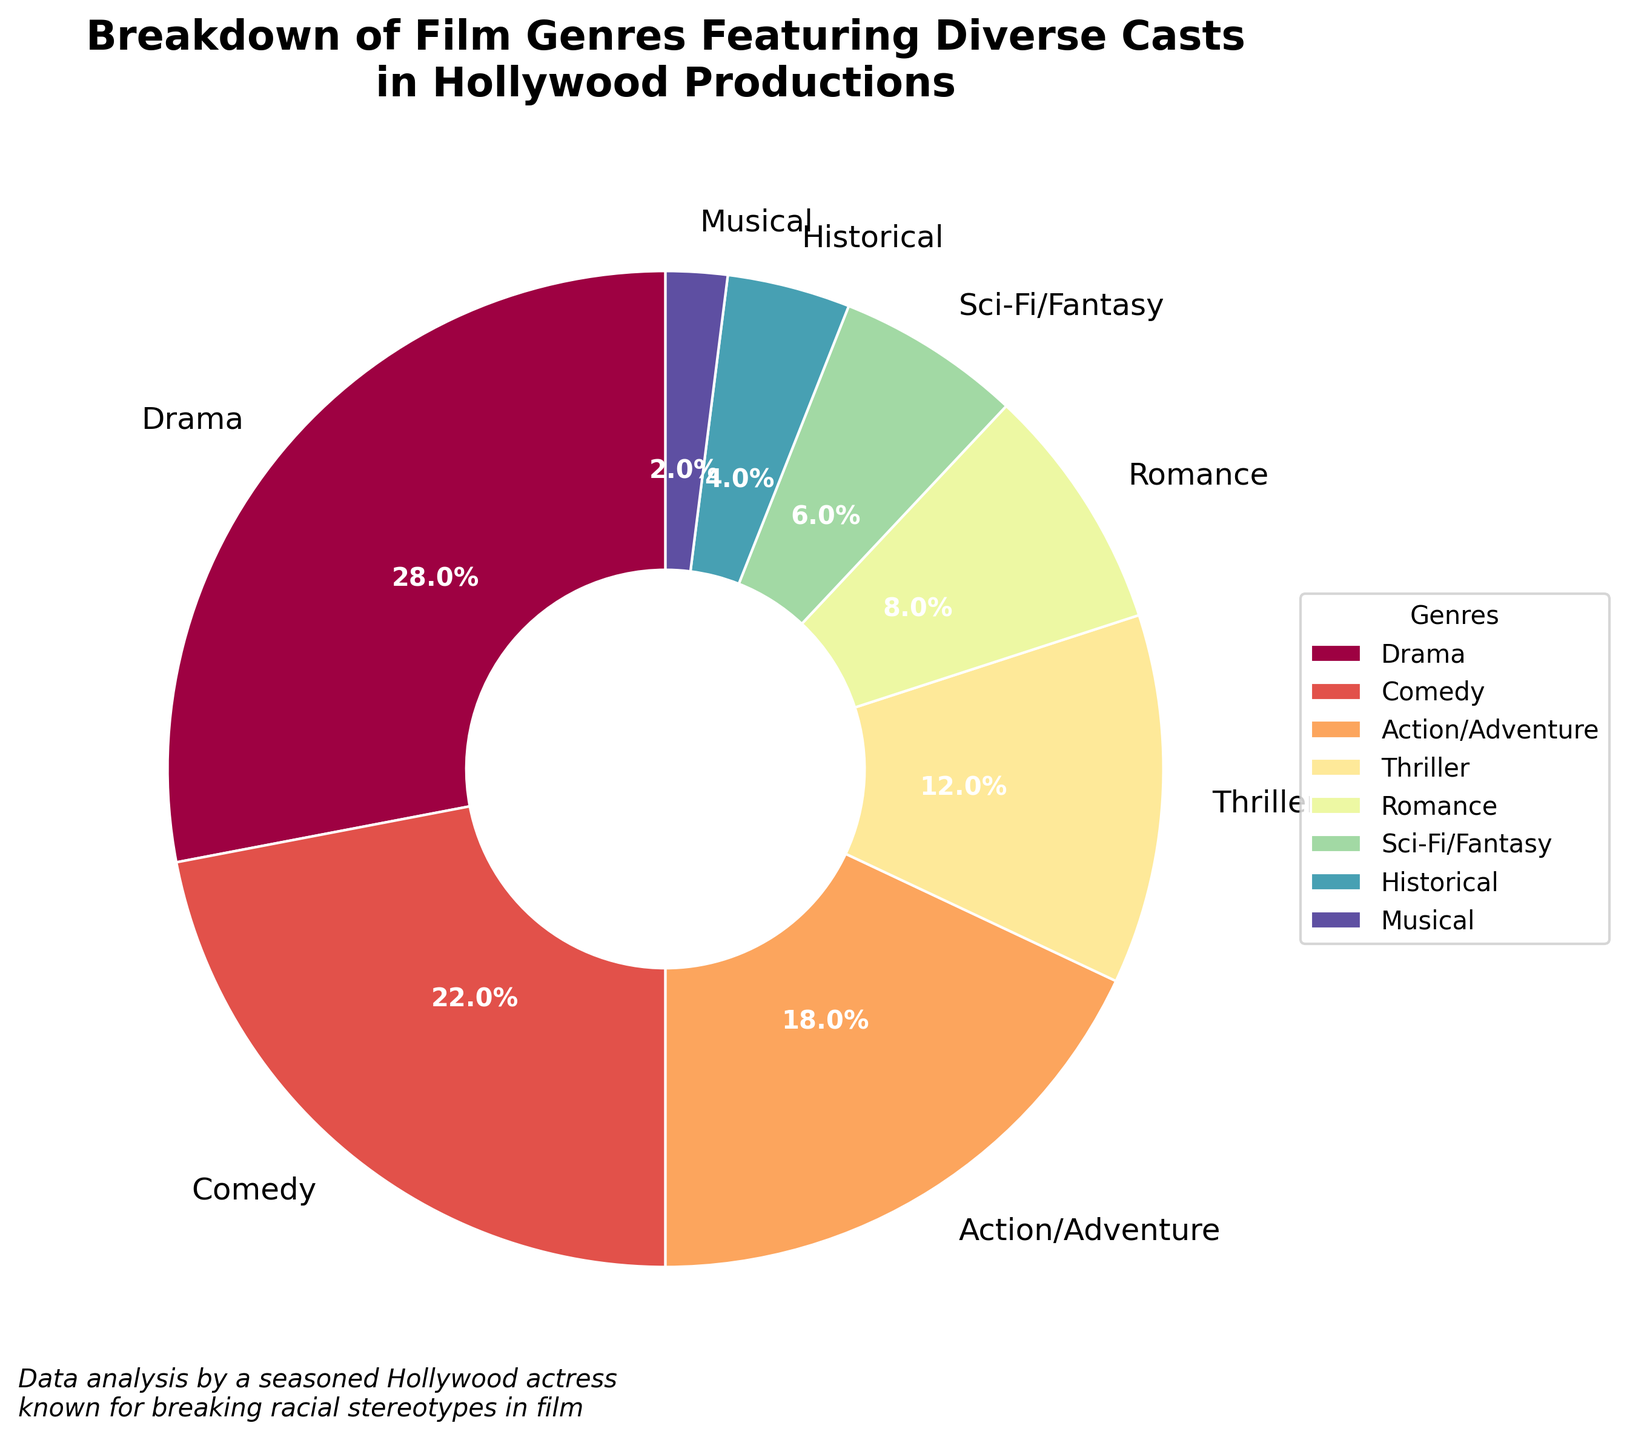Which genre has the highest percentage of films featuring diverse casts? The segment with the highest percentage shown in the pie chart is labeled 'Drama' with 28%.
Answer: Drama How much more prevalent is the Drama genre compared to the Romance genre? The Drama genre is at 28% and the Romance genre is at 8%, so the difference is 28% - 8% = 20%.
Answer: 20% What is the combined percentage of Comedy, Action/Adventure, and Thriller films? Adding the percentages of Comedy (22%), Action/Adventure (18%), and Thriller (12%) equals 22% + 18% + 12% = 52%.
Answer: 52% Which genre has the smallest percentage of films featuring diverse casts? The smallest segment in the pie chart is labeled 'Musical' with 2%.
Answer: Musical By how much does the percentage of Sci-Fi/Fantasy films exceed that of Historical films? The Sci-Fi/Fantasy genre is at 6% and the Historical genre is at 4%; hence, the difference is 6% - 4% = 2%.
Answer: 2% Are there more films categorized as Historical or as Romance? The pie chart shows that Historical films are at 4%, whereas Romance films are at 8%. Romance is higher.
Answer: Romance What is the total percentage of genres that are either Comedy or Action/Adventure? Adding the percentages of Comedy (22%) and Action/Adventure (18%) equals 22% + 18% = 40%.
Answer: 40% Which two genres have the closest percentages, and what are those percentages? The closest percentages are Sci-Fi/Fantasy at 6% and Historical at 4%, with a difference of 2%.
Answer: Sci-Fi/Fantasy and Historical, 6% and 4% Approximately what fraction of the pie chart is made up of Drama and Comedy combined? Drama (28%) and Comedy (22%) together add up to 50%. As a fraction, this is approximately 1/2 of the pie chart.
Answer: 1/2 What is the difference between the highest and lowest percentages in the pie chart? The highest percentage is of Drama at 28%, and the lowest is of Musical at 2%. The difference is 28% - 2% = 26%.
Answer: 26% 